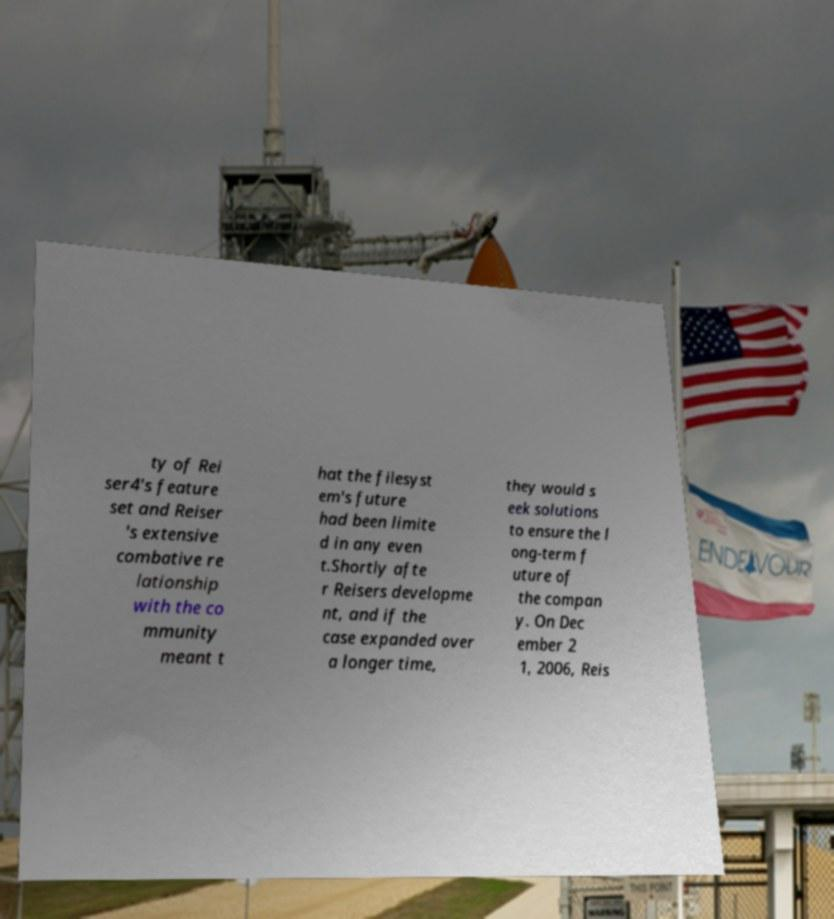For documentation purposes, I need the text within this image transcribed. Could you provide that? ty of Rei ser4's feature set and Reiser 's extensive combative re lationship with the co mmunity meant t hat the filesyst em's future had been limite d in any even t.Shortly afte r Reisers developme nt, and if the case expanded over a longer time, they would s eek solutions to ensure the l ong-term f uture of the compan y. On Dec ember 2 1, 2006, Reis 